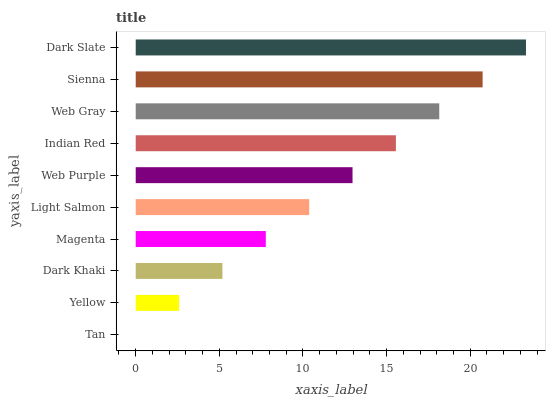Is Tan the minimum?
Answer yes or no. Yes. Is Dark Slate the maximum?
Answer yes or no. Yes. Is Yellow the minimum?
Answer yes or no. No. Is Yellow the maximum?
Answer yes or no. No. Is Yellow greater than Tan?
Answer yes or no. Yes. Is Tan less than Yellow?
Answer yes or no. Yes. Is Tan greater than Yellow?
Answer yes or no. No. Is Yellow less than Tan?
Answer yes or no. No. Is Web Purple the high median?
Answer yes or no. Yes. Is Light Salmon the low median?
Answer yes or no. Yes. Is Yellow the high median?
Answer yes or no. No. Is Indian Red the low median?
Answer yes or no. No. 